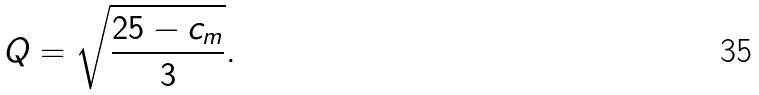<formula> <loc_0><loc_0><loc_500><loc_500>Q = \sqrt { \frac { 2 5 - c _ { m } } 3 } .</formula> 